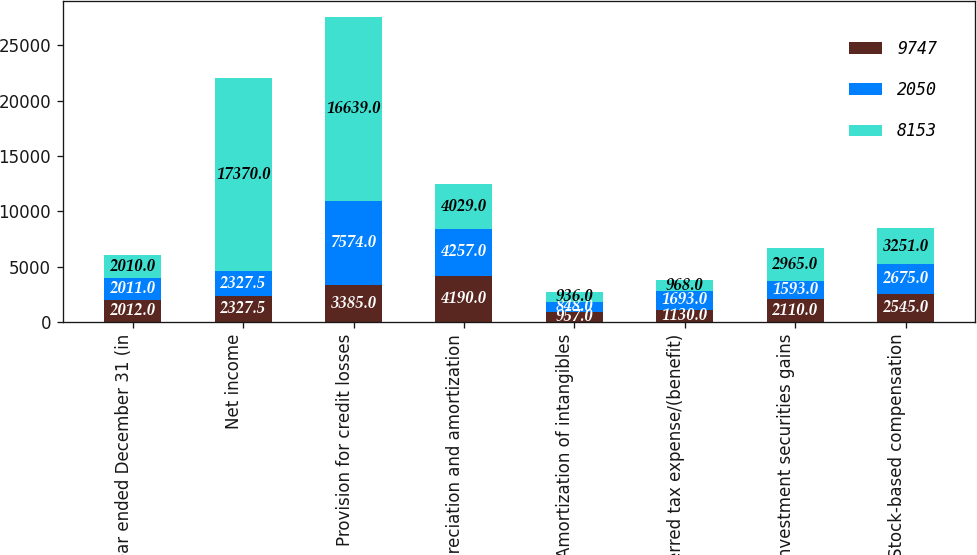Convert chart to OTSL. <chart><loc_0><loc_0><loc_500><loc_500><stacked_bar_chart><ecel><fcel>Year ended December 31 (in<fcel>Net income<fcel>Provision for credit losses<fcel>Depreciation and amortization<fcel>Amortization of intangibles<fcel>Deferred tax expense/(benefit)<fcel>Investment securities gains<fcel>Stock-based compensation<nl><fcel>9747<fcel>2012<fcel>2327.5<fcel>3385<fcel>4190<fcel>957<fcel>1130<fcel>2110<fcel>2545<nl><fcel>2050<fcel>2011<fcel>2327.5<fcel>7574<fcel>4257<fcel>848<fcel>1693<fcel>1593<fcel>2675<nl><fcel>8153<fcel>2010<fcel>17370<fcel>16639<fcel>4029<fcel>936<fcel>968<fcel>2965<fcel>3251<nl></chart> 